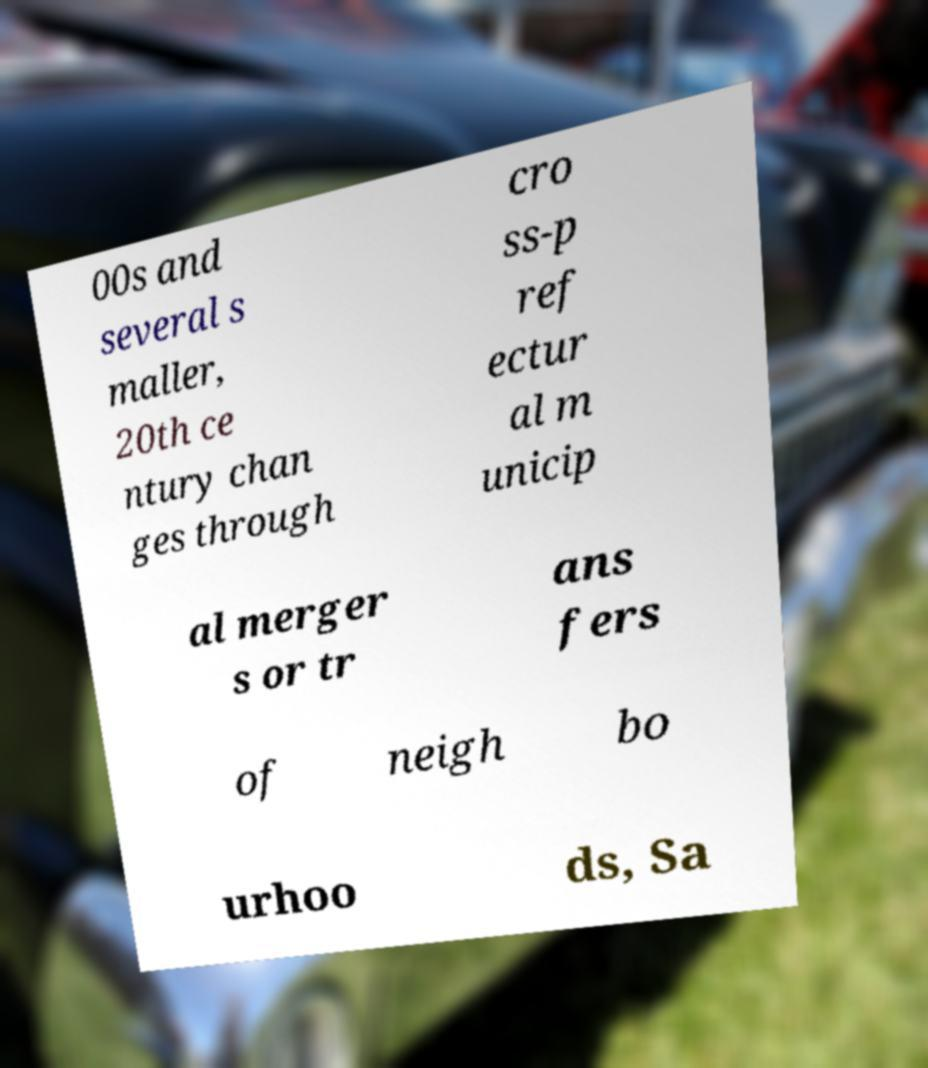Can you accurately transcribe the text from the provided image for me? 00s and several s maller, 20th ce ntury chan ges through cro ss-p ref ectur al m unicip al merger s or tr ans fers of neigh bo urhoo ds, Sa 